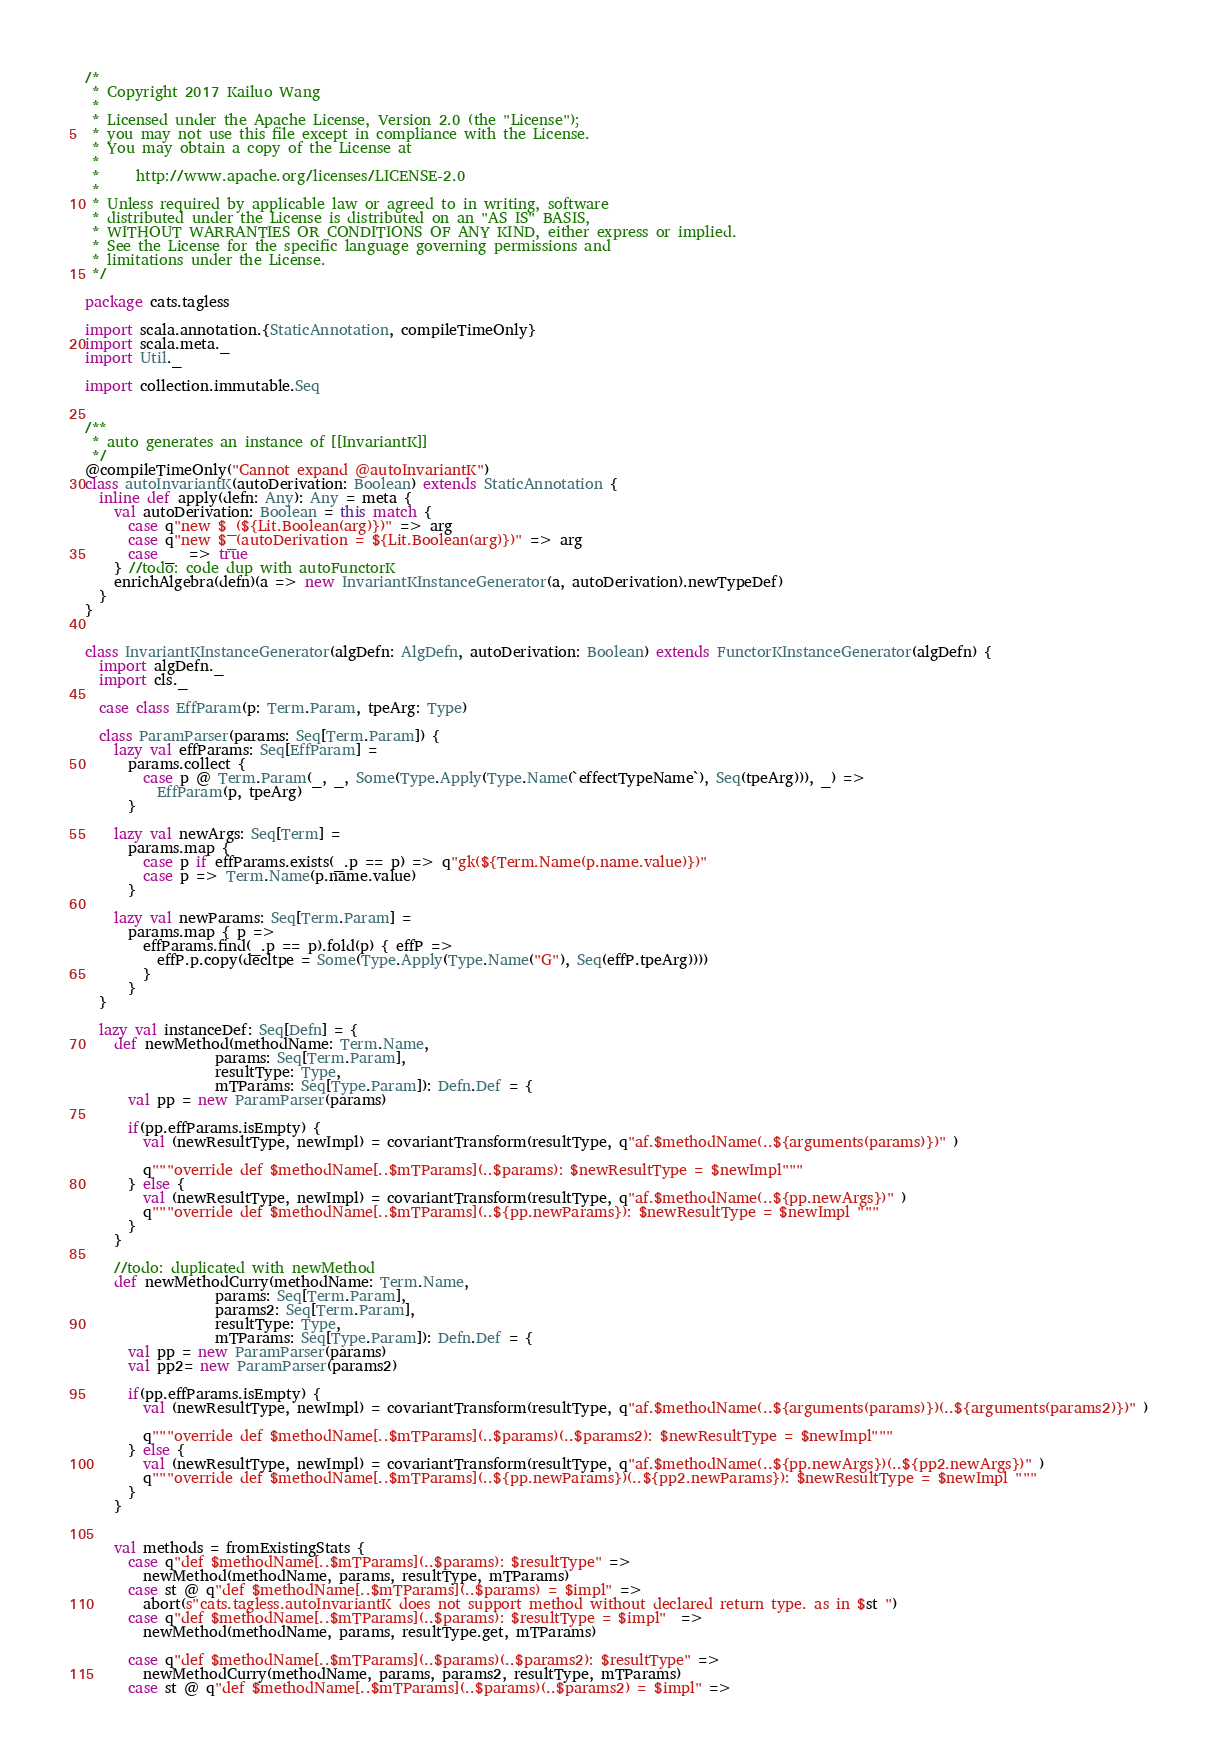<code> <loc_0><loc_0><loc_500><loc_500><_Scala_>/*
 * Copyright 2017 Kailuo Wang
 *
 * Licensed under the Apache License, Version 2.0 (the "License");
 * you may not use this file except in compliance with the License.
 * You may obtain a copy of the License at
 *
 *     http://www.apache.org/licenses/LICENSE-2.0
 *
 * Unless required by applicable law or agreed to in writing, software
 * distributed under the License is distributed on an "AS IS" BASIS,
 * WITHOUT WARRANTIES OR CONDITIONS OF ANY KIND, either express or implied.
 * See the License for the specific language governing permissions and
 * limitations under the License.
 */

package cats.tagless

import scala.annotation.{StaticAnnotation, compileTimeOnly}
import scala.meta._
import Util._

import collection.immutable.Seq


/**
 * auto generates an instance of [[InvariantK]]
 */
@compileTimeOnly("Cannot expand @autoInvariantK")
class autoInvariantK(autoDerivation: Boolean) extends StaticAnnotation {
  inline def apply(defn: Any): Any = meta {
    val autoDerivation: Boolean = this match {
      case q"new $_(${Lit.Boolean(arg)})" => arg
      case q"new $_(autoDerivation = ${Lit.Boolean(arg)})" => arg
      case _  => true
    } //todo: code dup with autoFunctorK
    enrichAlgebra(defn)(a => new InvariantKInstanceGenerator(a, autoDerivation).newTypeDef)
  }
}


class InvariantKInstanceGenerator(algDefn: AlgDefn, autoDerivation: Boolean) extends FunctorKInstanceGenerator(algDefn) {
  import algDefn._
  import cls._

  case class EffParam(p: Term.Param, tpeArg: Type)

  class ParamParser(params: Seq[Term.Param]) {
    lazy val effParams: Seq[EffParam] =
      params.collect {
        case p @ Term.Param(_, _, Some(Type.Apply(Type.Name(`effectTypeName`), Seq(tpeArg))), _) =>
          EffParam(p, tpeArg)
      }

    lazy val newArgs: Seq[Term] =
      params.map {
        case p if effParams.exists(_.p == p) => q"gk(${Term.Name(p.name.value)})"
        case p => Term.Name(p.name.value)
      }

    lazy val newParams: Seq[Term.Param] =
      params.map { p =>
        effParams.find(_.p == p).fold(p) { effP =>
          effP.p.copy(decltpe = Some(Type.Apply(Type.Name("G"), Seq(effP.tpeArg))))
        }
      }
  }

  lazy val instanceDef: Seq[Defn] = {
    def newMethod(methodName: Term.Name,
                  params: Seq[Term.Param],
                  resultType: Type,
                  mTParams: Seq[Type.Param]): Defn.Def = {
      val pp = new ParamParser(params)

      if(pp.effParams.isEmpty) {
        val (newResultType, newImpl) = covariantTransform(resultType, q"af.$methodName(..${arguments(params)})" )

        q"""override def $methodName[..$mTParams](..$params): $newResultType = $newImpl"""
      } else {
        val (newResultType, newImpl) = covariantTransform(resultType, q"af.$methodName(..${pp.newArgs})" )
        q"""override def $methodName[..$mTParams](..${pp.newParams}): $newResultType = $newImpl """
      }
    }

    //todo: duplicated with newMethod
    def newMethodCurry(methodName: Term.Name,
                  params: Seq[Term.Param],
                  params2: Seq[Term.Param],
                  resultType: Type,
                  mTParams: Seq[Type.Param]): Defn.Def = {
      val pp = new ParamParser(params)
      val pp2= new ParamParser(params2)

      if(pp.effParams.isEmpty) {
        val (newResultType, newImpl) = covariantTransform(resultType, q"af.$methodName(..${arguments(params)})(..${arguments(params2)})" )

        q"""override def $methodName[..$mTParams](..$params)(..$params2): $newResultType = $newImpl"""
      } else {
        val (newResultType, newImpl) = covariantTransform(resultType, q"af.$methodName(..${pp.newArgs})(..${pp2.newArgs})" )
        q"""override def $methodName[..$mTParams](..${pp.newParams})(..${pp2.newParams}): $newResultType = $newImpl """
      }
    }


    val methods = fromExistingStats {
      case q"def $methodName[..$mTParams](..$params): $resultType" =>
        newMethod(methodName, params, resultType, mTParams)
      case st @ q"def $methodName[..$mTParams](..$params) = $impl" =>
        abort(s"cats.tagless.autoInvariantK does not support method without declared return type. as in $st ")
      case q"def $methodName[..$mTParams](..$params): $resultType = $impl"  =>
        newMethod(methodName, params, resultType.get, mTParams)

      case q"def $methodName[..$mTParams](..$params)(..$params2): $resultType" =>
        newMethodCurry(methodName, params, params2, resultType, mTParams)
      case st @ q"def $methodName[..$mTParams](..$params)(..$params2) = $impl" =></code> 